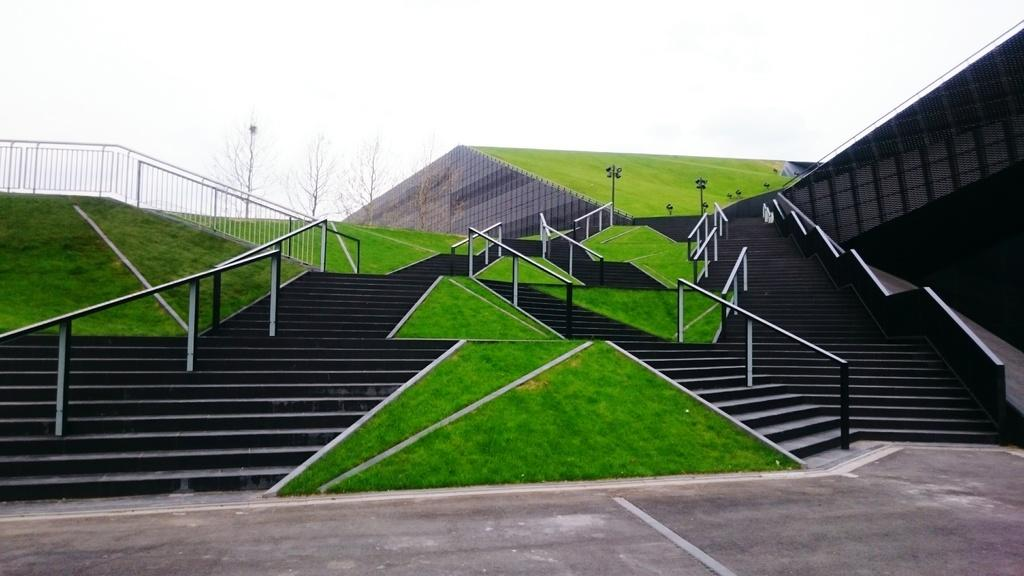What type of structure is present in the image? There is a building in the image. What architectural feature is visible near the building? There are stairs in the image. What safety feature is present near the stairs? There are railings in the image. What can be seen in the background of the image? There are trees, poles, and the sky visible in the background of the image. What is at the bottom of the image? There is a road at the bottom of the image. What type of cord is hanging from the trees in the image? There is no cord hanging from the trees in the image. What flavor of burst can be tasted in the image? There is no burst or taste present in the image. 